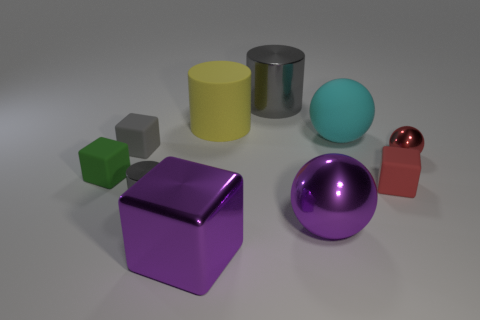There is a big purple object that is behind the shiny cube; what material is it? The big purple object appears to be a sphere with a smooth surface, likely made of a material like plastic or polished metal, as it reflects light and has a lustrous finish. 